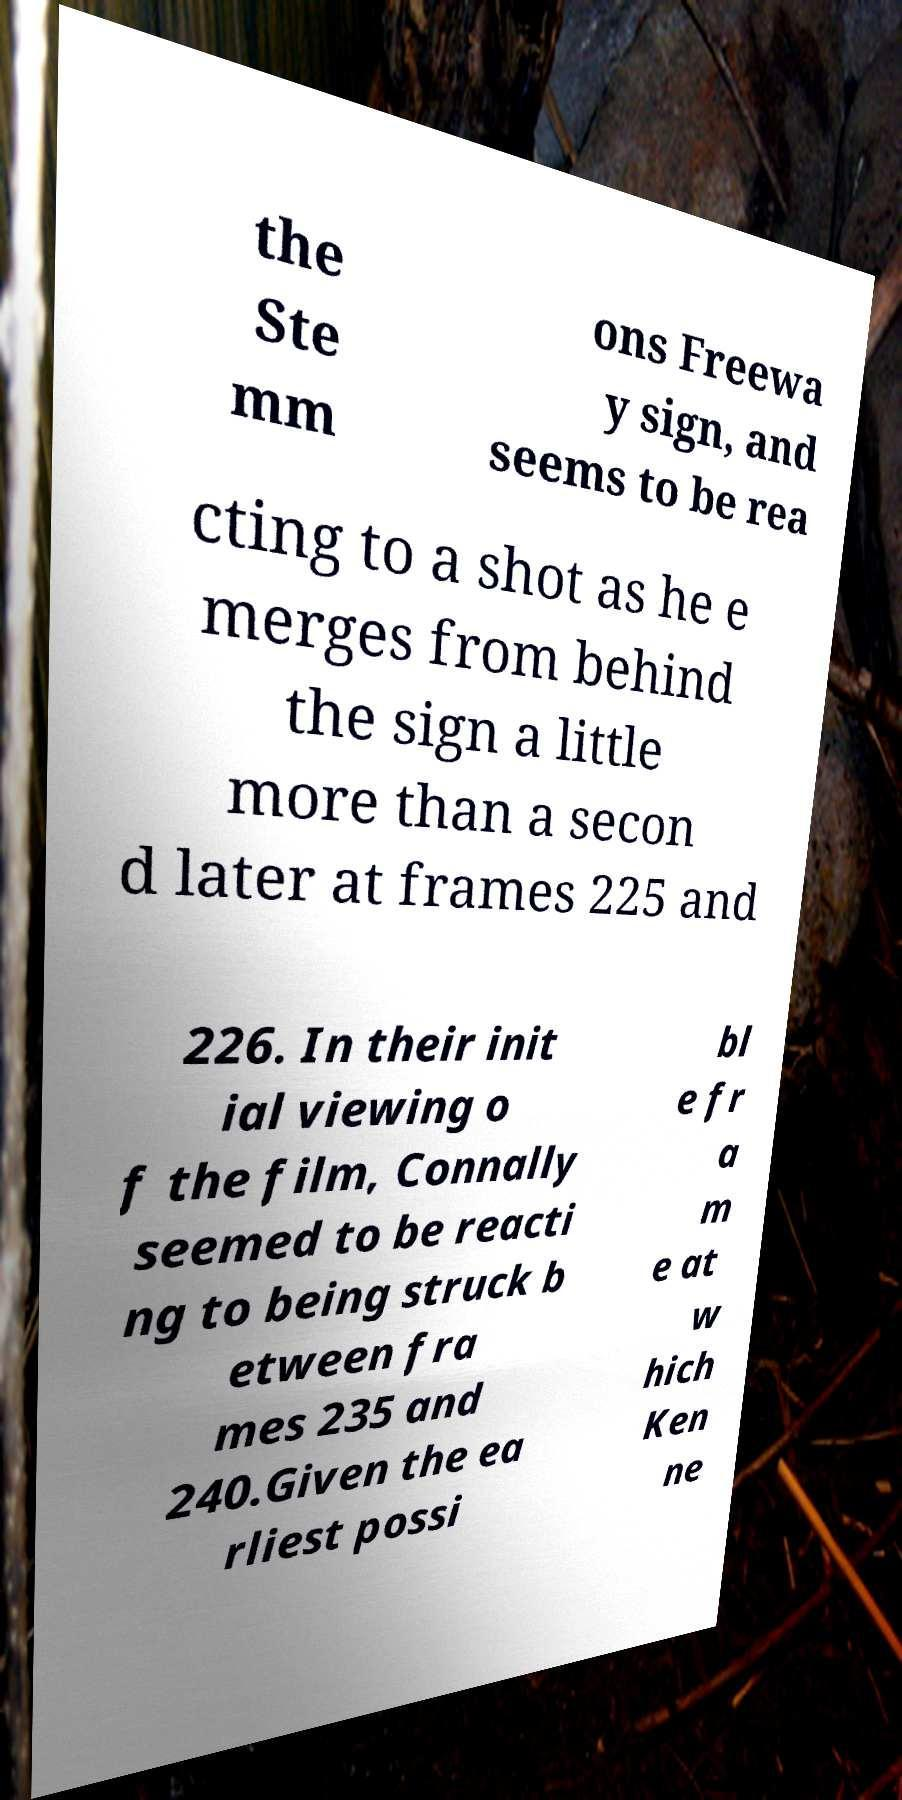What messages or text are displayed in this image? I need them in a readable, typed format. the Ste mm ons Freewa y sign, and seems to be rea cting to a shot as he e merges from behind the sign a little more than a secon d later at frames 225 and 226. In their init ial viewing o f the film, Connally seemed to be reacti ng to being struck b etween fra mes 235 and 240.Given the ea rliest possi bl e fr a m e at w hich Ken ne 